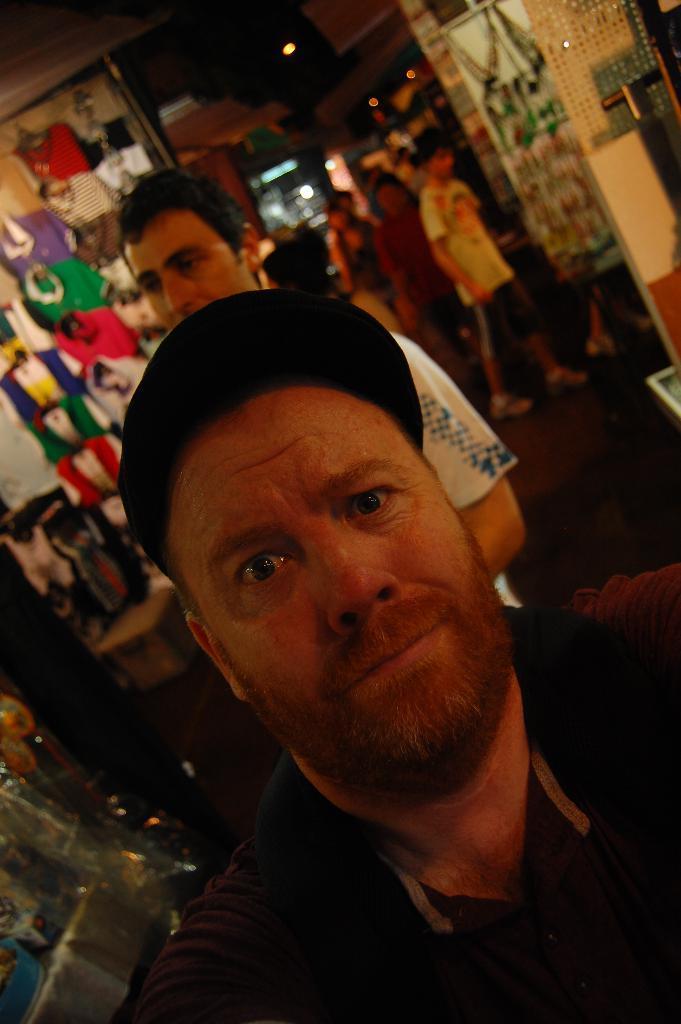Could you give a brief overview of what you see in this image? This picture describes about group of people, in the middle of the image we can see a man, he wore a cap, behind him we can see few clothes, lights and other things. 